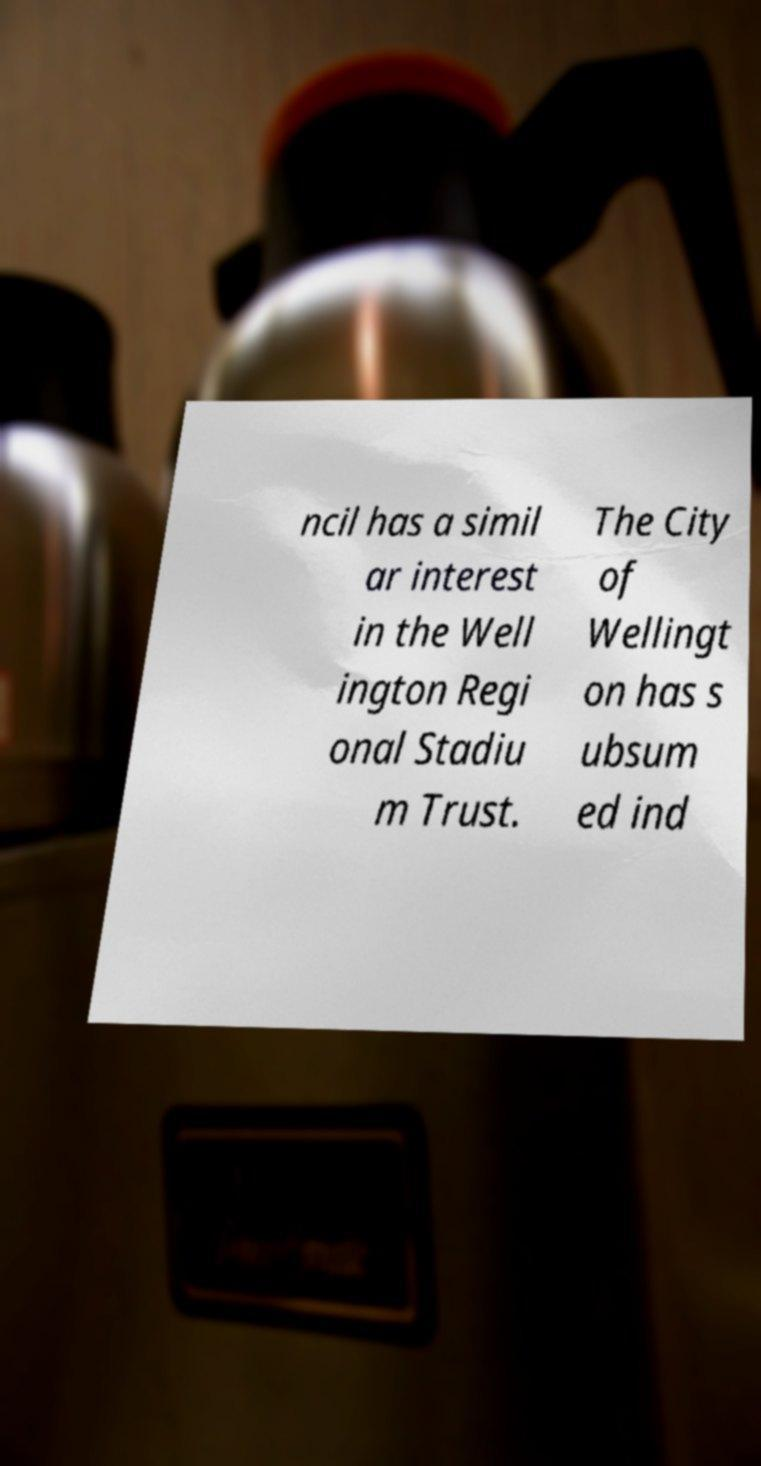Could you extract and type out the text from this image? ncil has a simil ar interest in the Well ington Regi onal Stadiu m Trust. The City of Wellingt on has s ubsum ed ind 